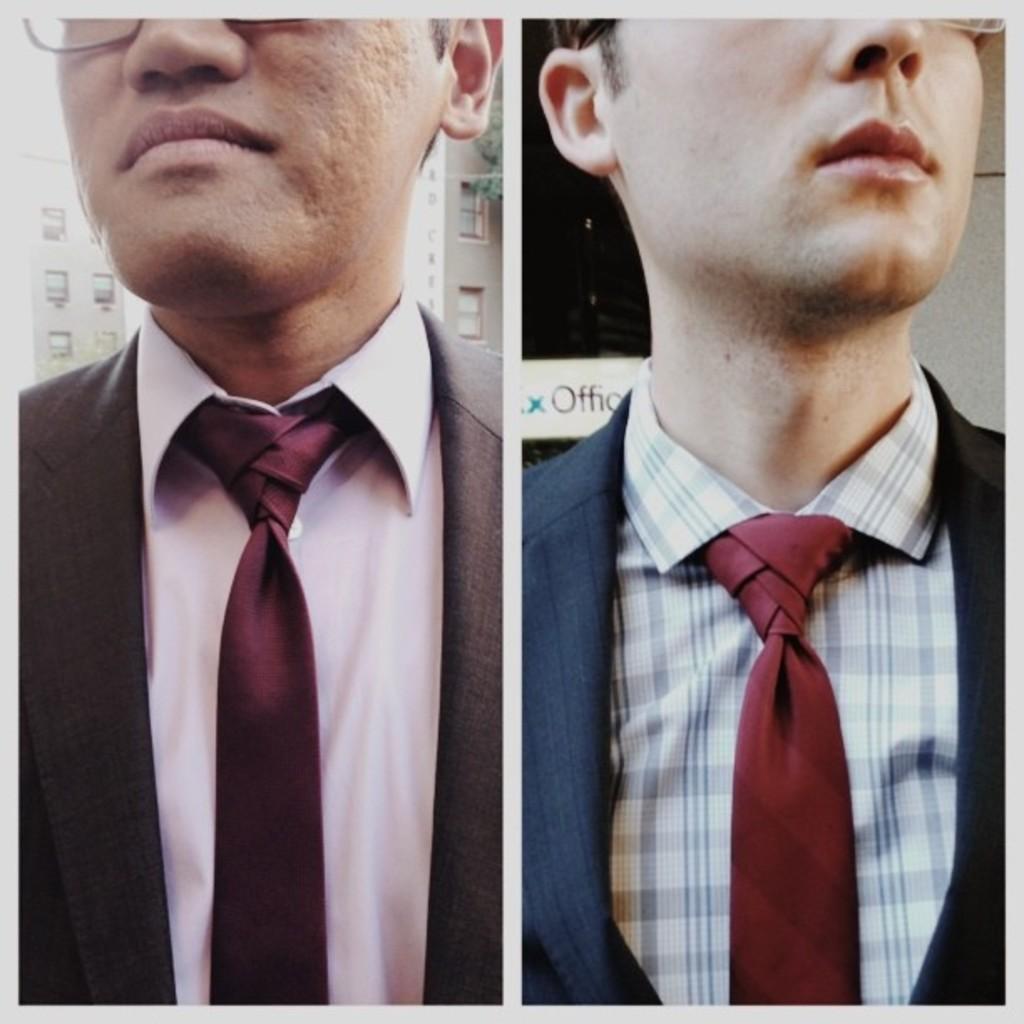How would you summarize this image in a sentence or two? This picture is a collage of 2 images. On the right side there is a person wearing blue colour suit and a red colour tie and a shirt and in the background there is an object which is black in colour and there is a board with some text written on it which is white in colour. On the left side of the image there is a person wearing brown colour suit, pink colour shirt and red colour tie and in the background there is a building and there is an object which is green in colour and the person is wearing specs. 